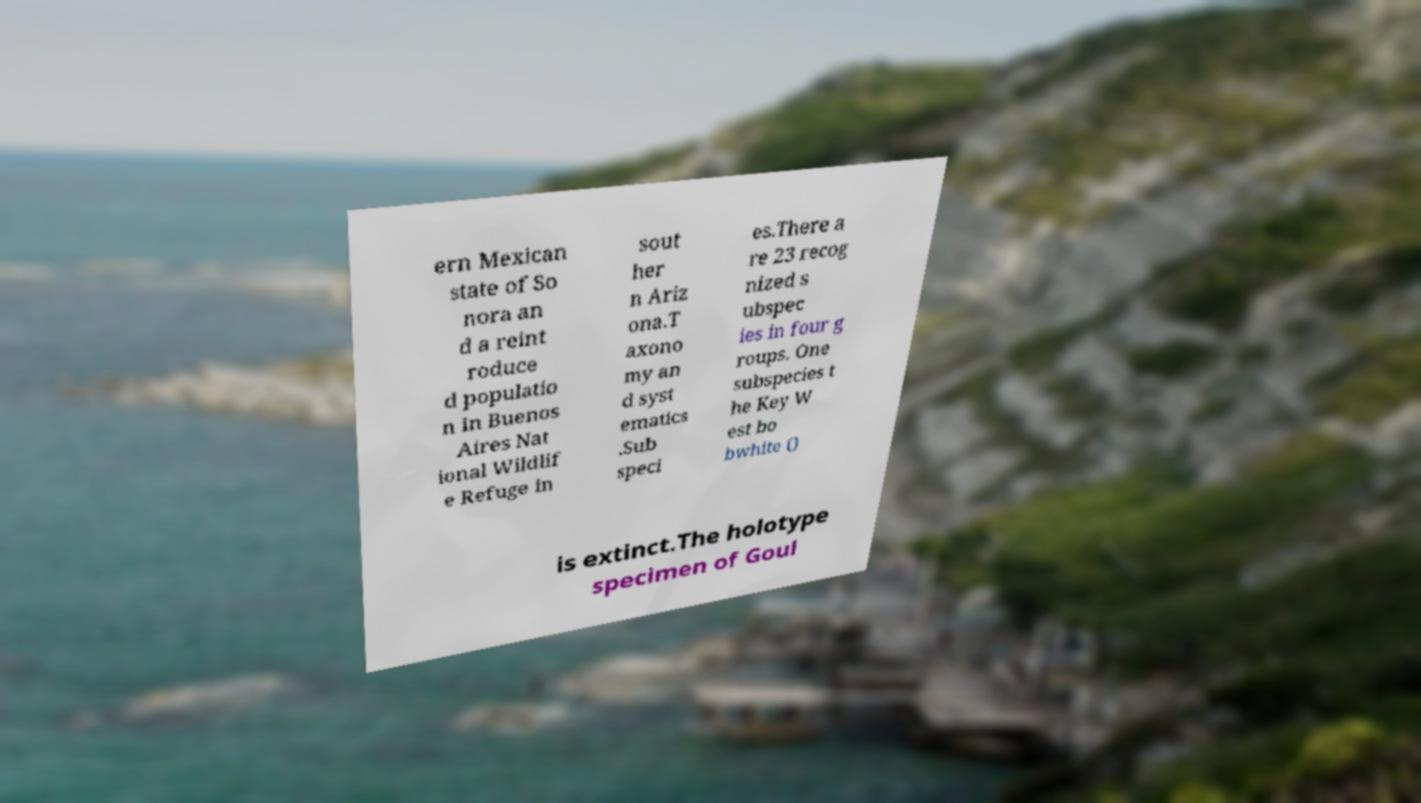Could you assist in decoding the text presented in this image and type it out clearly? ern Mexican state of So nora an d a reint roduce d populatio n in Buenos Aires Nat ional Wildlif e Refuge in sout her n Ariz ona.T axono my an d syst ematics .Sub speci es.There a re 23 recog nized s ubspec ies in four g roups. One subspecies t he Key W est bo bwhite () is extinct.The holotype specimen of Goul 